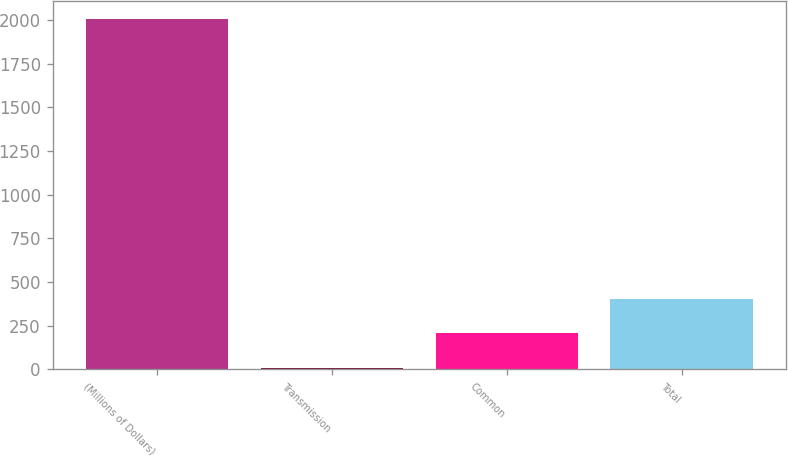Convert chart. <chart><loc_0><loc_0><loc_500><loc_500><bar_chart><fcel>(Millions of Dollars)<fcel>Transmission<fcel>Common<fcel>Total<nl><fcel>2007<fcel>6<fcel>206.1<fcel>406.2<nl></chart> 